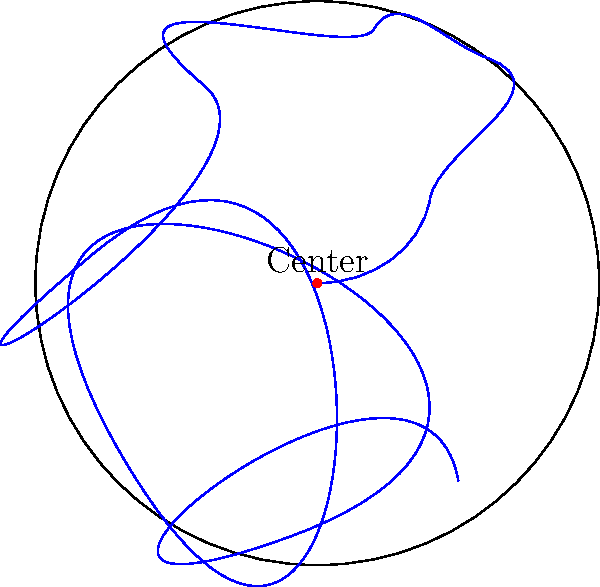Consider the spiral groove pattern on a vinyl record, as shown in the diagram. What is the order of the symmetry group for this pattern, assuming the record is centered at the origin? To determine the order of the symmetry group for the spiral groove pattern on a vinyl record, we need to consider the following steps:

1. Rotational symmetry: The spiral pattern does not exhibit any rotational symmetry other than a full 360° rotation (identity transformation). This is because the spiral continuously changes its distance from the center as it rotates.

2. Reflection symmetry: The spiral pattern does not have any lines of reflection symmetry. Reflecting the spiral would change its direction (clockwise to counterclockwise or vice versa).

3. Translation symmetry: There is no translation symmetry in this pattern, as the spiral is centered at a fixed point.

4. Identity transformation: The only symmetry operation that leaves the pattern unchanged is the identity transformation (doing nothing).

Therefore, the symmetry group of the vinyl record's spiral groove pattern consists of only one element: the identity transformation.

In group theory, the order of a group is the number of elements in the group. Since there is only one element (the identity transformation) in this symmetry group, the order of the group is 1.

This type of group is known as the trivial group, which is the simplest possible group containing only the identity element.
Answer: 1 (trivial group) 